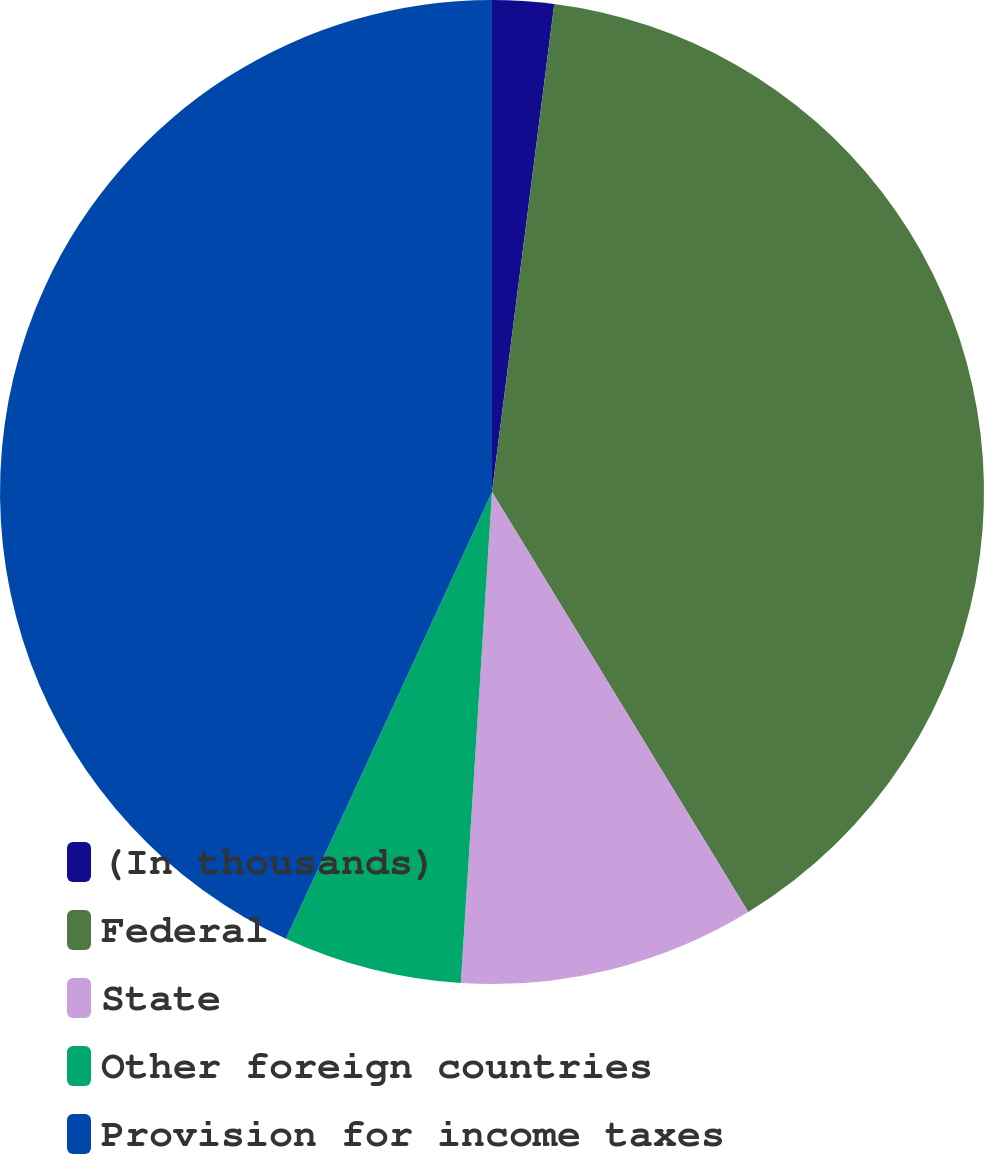Convert chart to OTSL. <chart><loc_0><loc_0><loc_500><loc_500><pie_chart><fcel>(In thousands)<fcel>Federal<fcel>State<fcel>Other foreign countries<fcel>Provision for income taxes<nl><fcel>2.02%<fcel>39.26%<fcel>9.73%<fcel>5.87%<fcel>43.12%<nl></chart> 